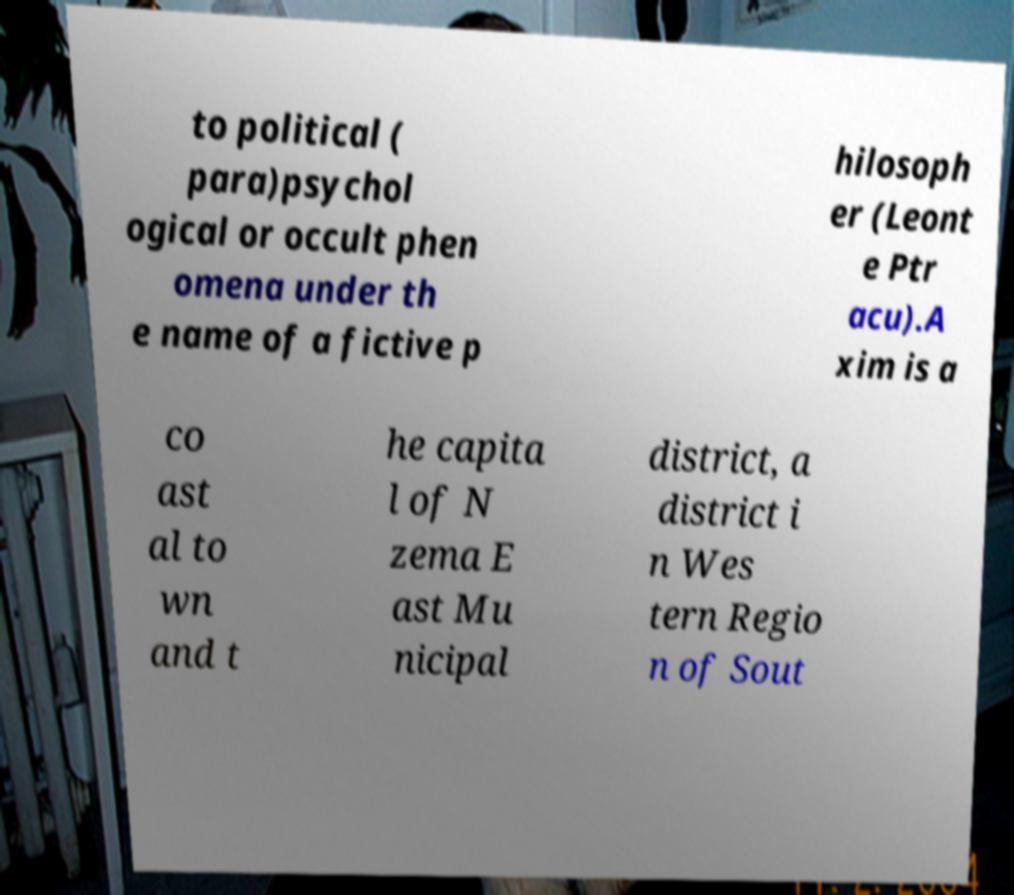Could you extract and type out the text from this image? to political ( para)psychol ogical or occult phen omena under th e name of a fictive p hilosoph er (Leont e Ptr acu).A xim is a co ast al to wn and t he capita l of N zema E ast Mu nicipal district, a district i n Wes tern Regio n of Sout 